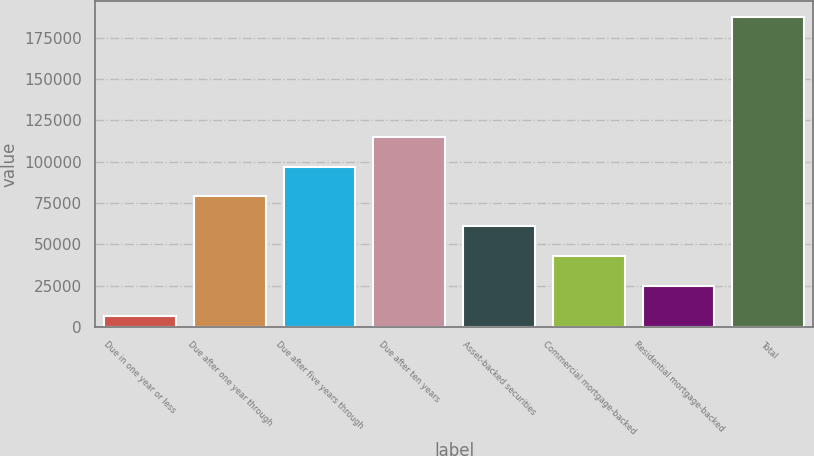Convert chart. <chart><loc_0><loc_0><loc_500><loc_500><bar_chart><fcel>Due in one year or less<fcel>Due after one year through<fcel>Due after five years through<fcel>Due after ten years<fcel>Asset-backed securities<fcel>Commercial mortgage-backed<fcel>Residential mortgage-backed<fcel>Total<nl><fcel>6401<fcel>78942.2<fcel>97077.5<fcel>115213<fcel>60806.9<fcel>42671.6<fcel>24536.3<fcel>187754<nl></chart> 